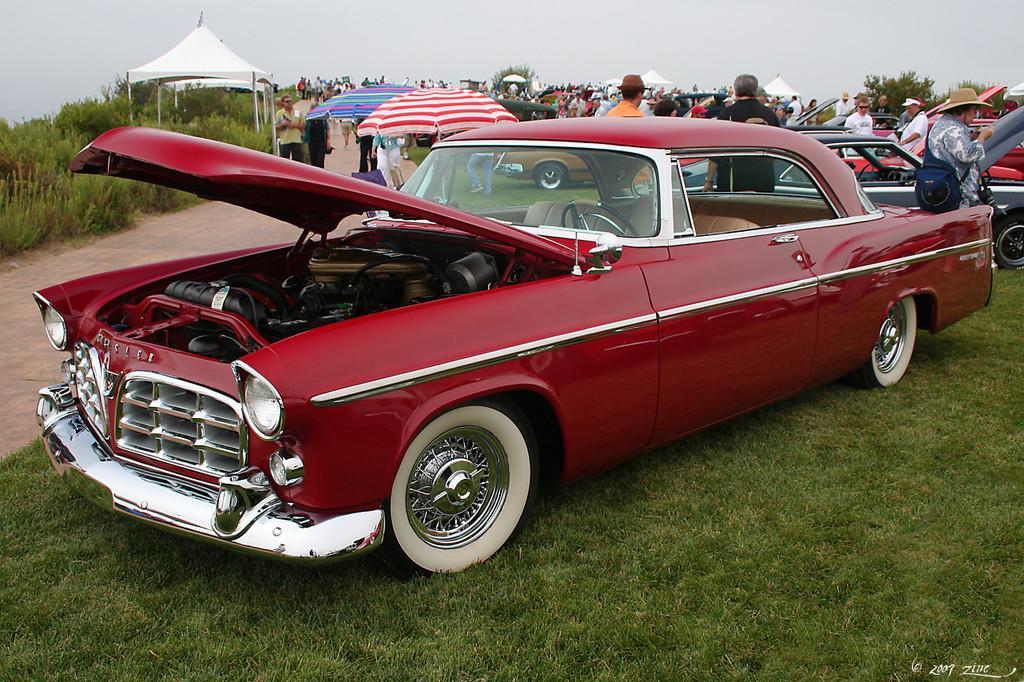Please provide a concise description of this image. In this image I can see few vehicles, umbrellas, tents, plants, sky and few people around. 